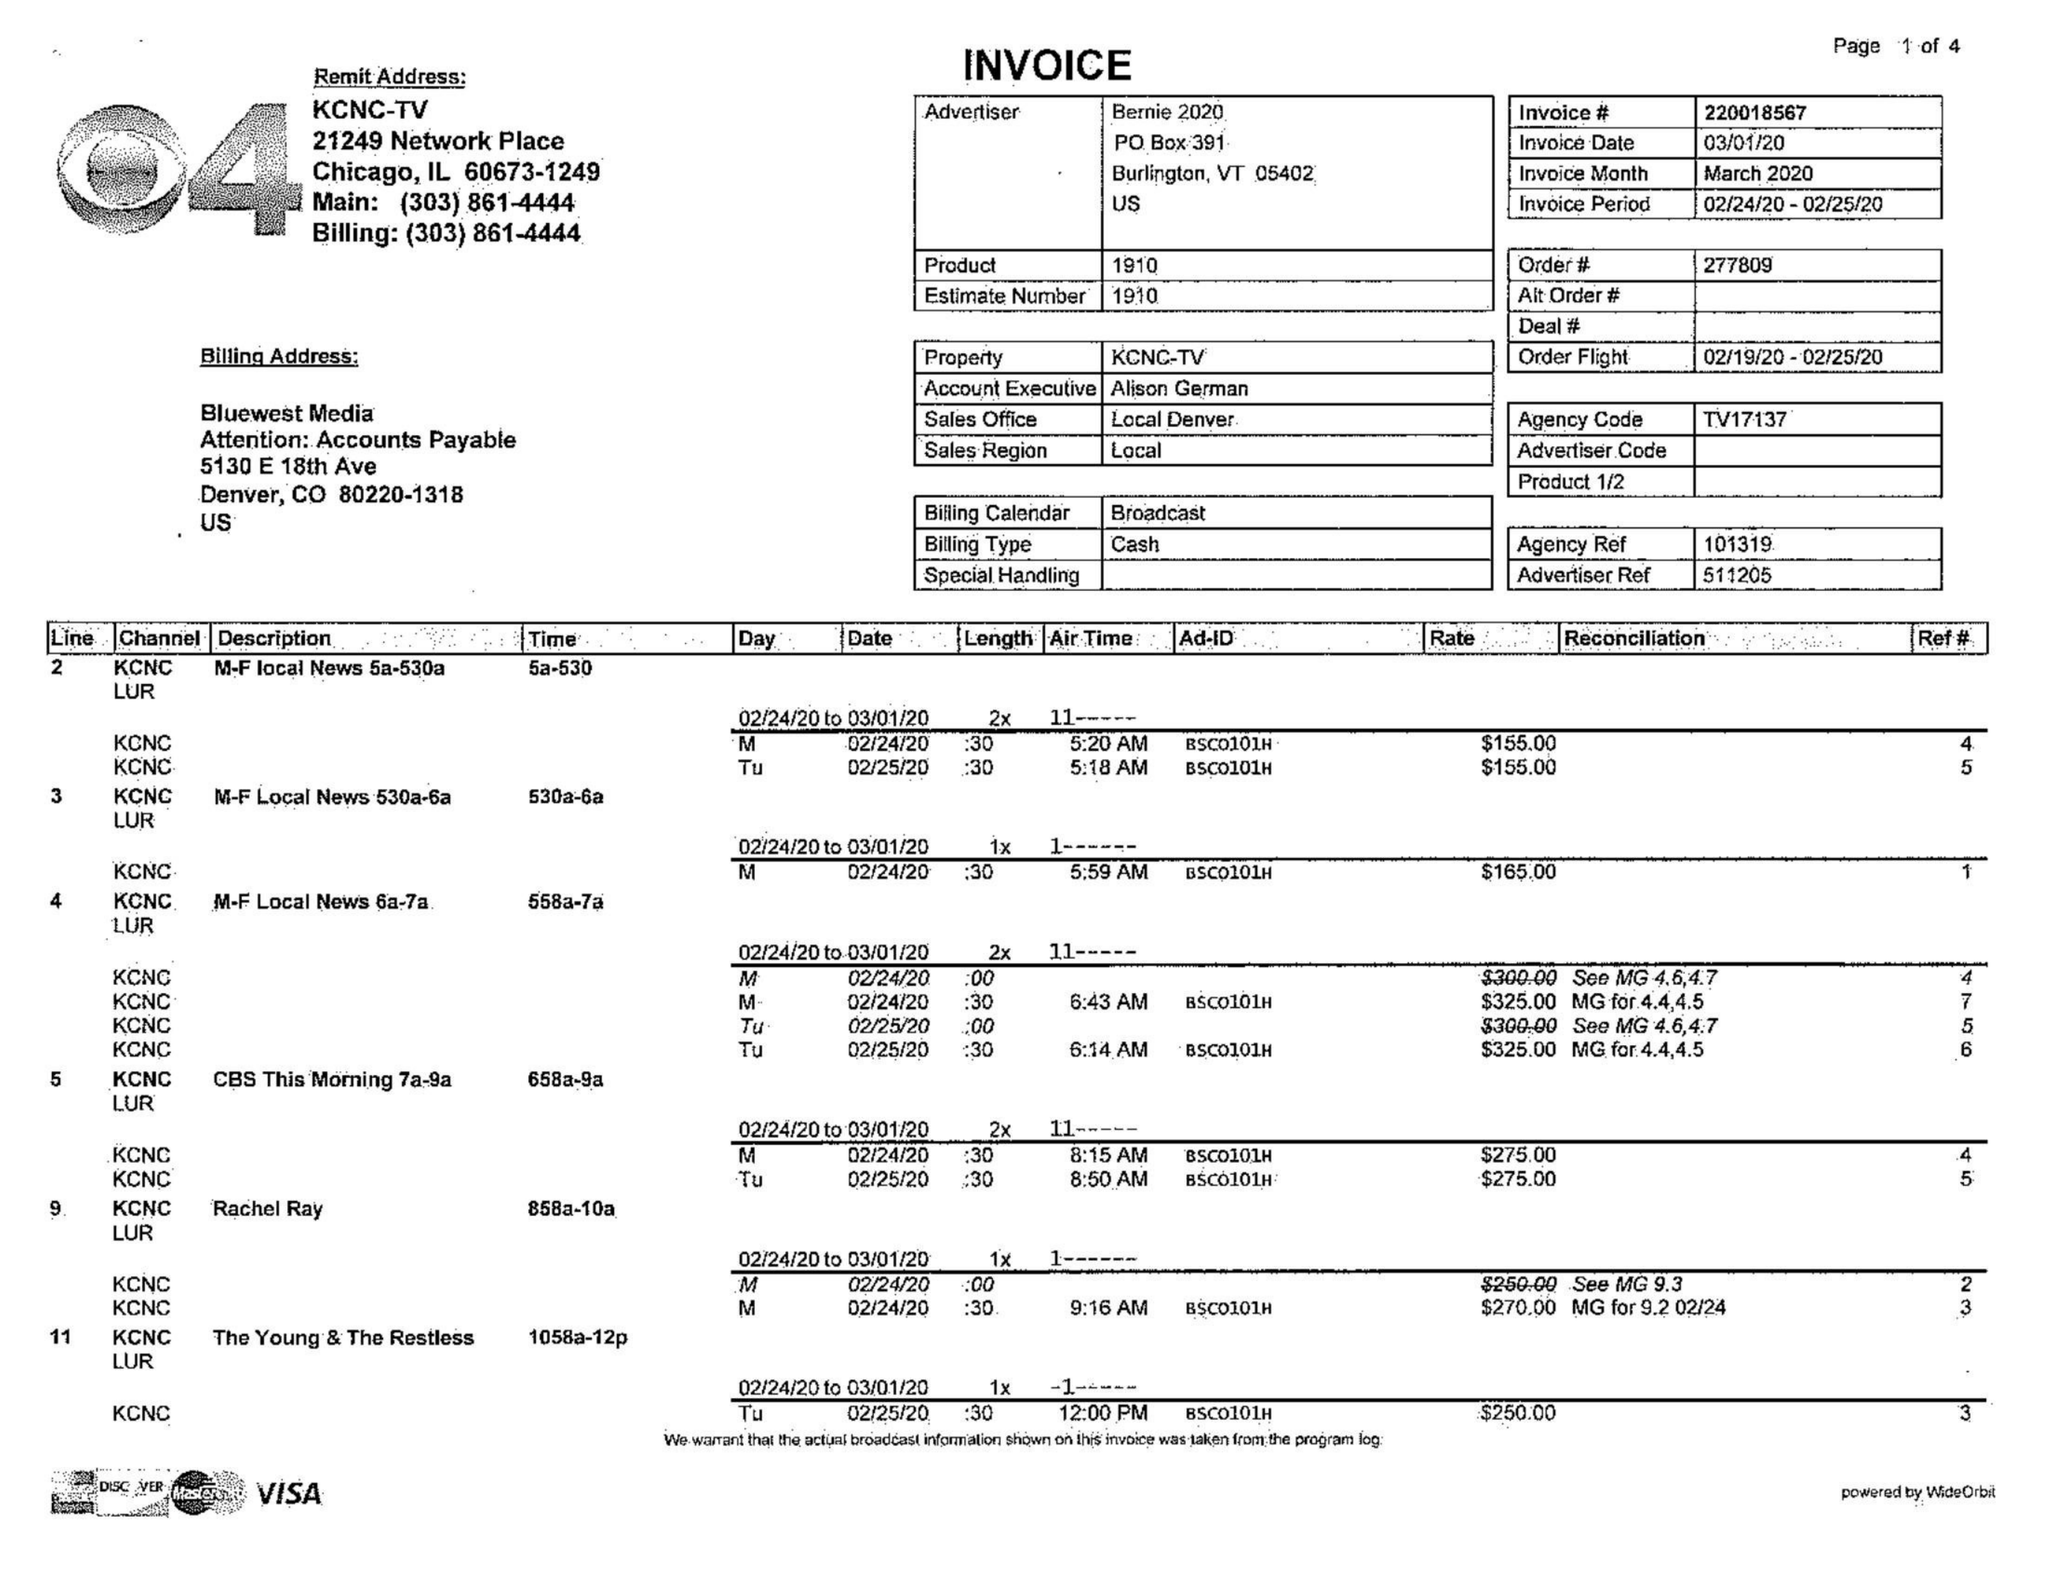What is the value for the flight_from?
Answer the question using a single word or phrase. 02/19/20 